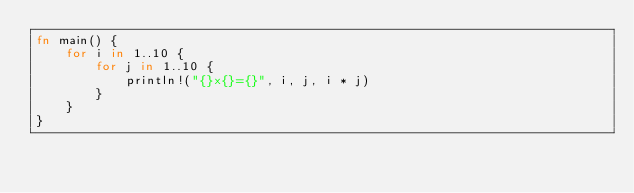Convert code to text. <code><loc_0><loc_0><loc_500><loc_500><_Rust_>fn main() {
    for i in 1..10 {
        for j in 1..10 {
            println!("{}x{}={}", i, j, i * j)
        }
    }
}

</code> 